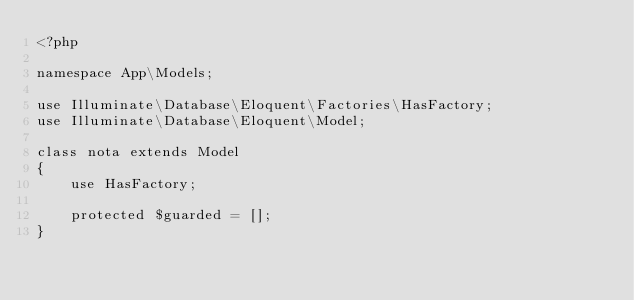Convert code to text. <code><loc_0><loc_0><loc_500><loc_500><_PHP_><?php

namespace App\Models;

use Illuminate\Database\Eloquent\Factories\HasFactory;
use Illuminate\Database\Eloquent\Model;

class nota extends Model
{
    use HasFactory;

    protected $guarded = [];
}
</code> 